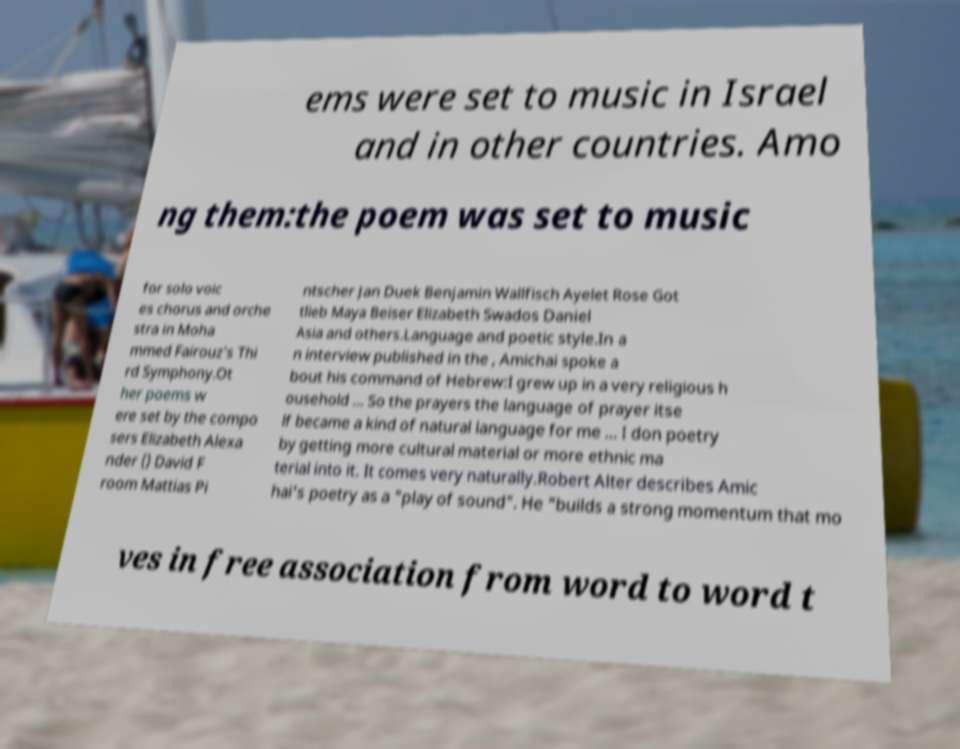Can you accurately transcribe the text from the provided image for me? ems were set to music in Israel and in other countries. Amo ng them:the poem was set to music for solo voic es chorus and orche stra in Moha mmed Fairouz's Thi rd Symphony.Ot her poems w ere set by the compo sers Elizabeth Alexa nder () David F room Mattias Pi ntscher Jan Duek Benjamin Wallfisch Ayelet Rose Got tlieb Maya Beiser Elizabeth Swados Daniel Asia and others.Language and poetic style.In a n interview published in the , Amichai spoke a bout his command of Hebrew:I grew up in a very religious h ousehold ... So the prayers the language of prayer itse lf became a kind of natural language for me ... I don poetry by getting more cultural material or more ethnic ma terial into it. It comes very naturally.Robert Alter describes Amic hai's poetry as a "play of sound". He "builds a strong momentum that mo ves in free association from word to word t 